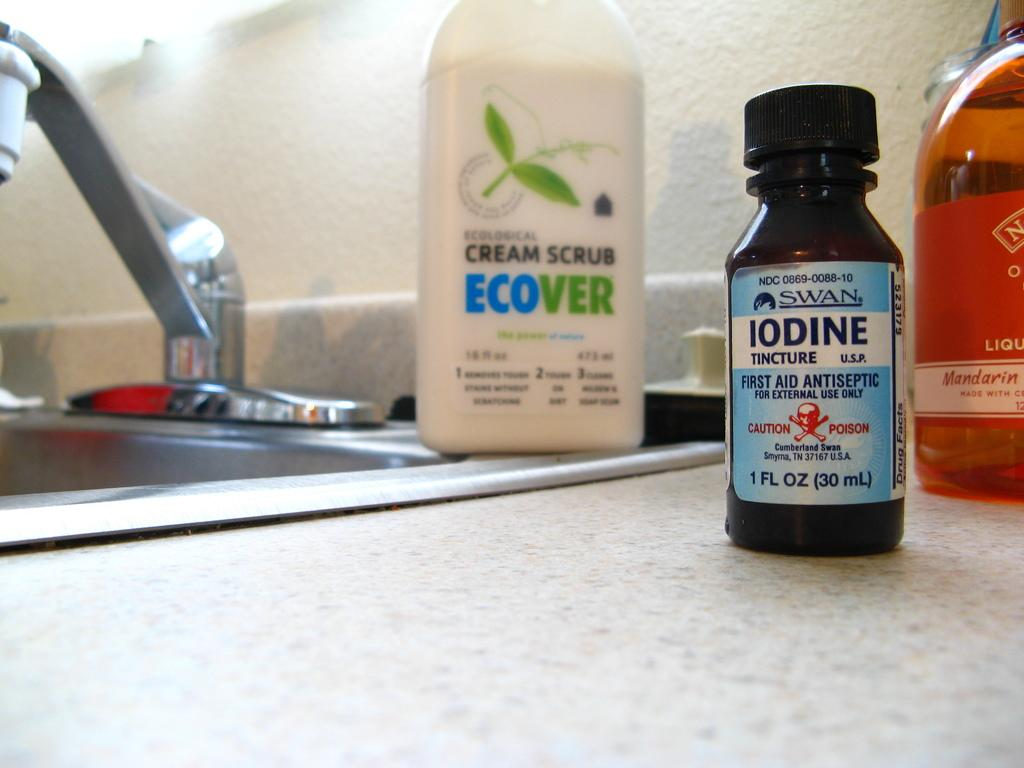What type of bottle is present in the image? There is an antiseptic bottle in the image. How many other bottles are in the image? There are two other bottles in the image. What can be found in the background of the image? There is a sink in the image. What type of design is featured on the antiseptic bottle in the image? There is no information about the design on the antiseptic bottle in the image. Is there any eggnog present in the image? There is no mention of eggnog in the image. 